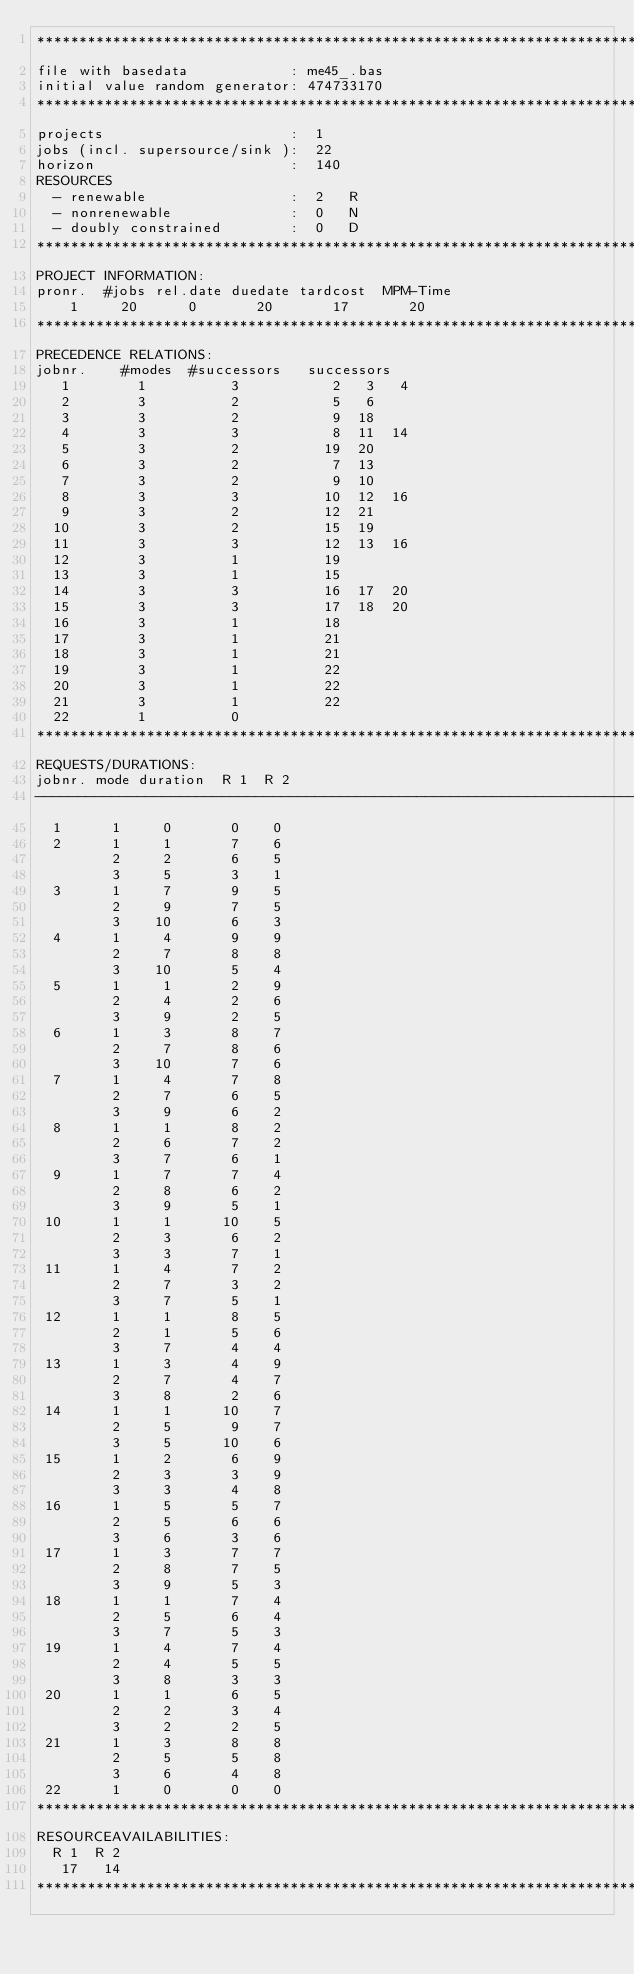Convert code to text. <code><loc_0><loc_0><loc_500><loc_500><_ObjectiveC_>************************************************************************
file with basedata            : me45_.bas
initial value random generator: 474733170
************************************************************************
projects                      :  1
jobs (incl. supersource/sink ):  22
horizon                       :  140
RESOURCES
  - renewable                 :  2   R
  - nonrenewable              :  0   N
  - doubly constrained        :  0   D
************************************************************************
PROJECT INFORMATION:
pronr.  #jobs rel.date duedate tardcost  MPM-Time
    1     20      0       20       17       20
************************************************************************
PRECEDENCE RELATIONS:
jobnr.    #modes  #successors   successors
   1        1          3           2   3   4
   2        3          2           5   6
   3        3          2           9  18
   4        3          3           8  11  14
   5        3          2          19  20
   6        3          2           7  13
   7        3          2           9  10
   8        3          3          10  12  16
   9        3          2          12  21
  10        3          2          15  19
  11        3          3          12  13  16
  12        3          1          19
  13        3          1          15
  14        3          3          16  17  20
  15        3          3          17  18  20
  16        3          1          18
  17        3          1          21
  18        3          1          21
  19        3          1          22
  20        3          1          22
  21        3          1          22
  22        1          0        
************************************************************************
REQUESTS/DURATIONS:
jobnr. mode duration  R 1  R 2
------------------------------------------------------------------------
  1      1     0       0    0
  2      1     1       7    6
         2     2       6    5
         3     5       3    1
  3      1     7       9    5
         2     9       7    5
         3    10       6    3
  4      1     4       9    9
         2     7       8    8
         3    10       5    4
  5      1     1       2    9
         2     4       2    6
         3     9       2    5
  6      1     3       8    7
         2     7       8    6
         3    10       7    6
  7      1     4       7    8
         2     7       6    5
         3     9       6    2
  8      1     1       8    2
         2     6       7    2
         3     7       6    1
  9      1     7       7    4
         2     8       6    2
         3     9       5    1
 10      1     1      10    5
         2     3       6    2
         3     3       7    1
 11      1     4       7    2
         2     7       3    2
         3     7       5    1
 12      1     1       8    5
         2     1       5    6
         3     7       4    4
 13      1     3       4    9
         2     7       4    7
         3     8       2    6
 14      1     1      10    7
         2     5       9    7
         3     5      10    6
 15      1     2       6    9
         2     3       3    9
         3     3       4    8
 16      1     5       5    7
         2     5       6    6
         3     6       3    6
 17      1     3       7    7
         2     8       7    5
         3     9       5    3
 18      1     1       7    4
         2     5       6    4
         3     7       5    3
 19      1     4       7    4
         2     4       5    5
         3     8       3    3
 20      1     1       6    5
         2     2       3    4
         3     2       2    5
 21      1     3       8    8
         2     5       5    8
         3     6       4    8
 22      1     0       0    0
************************************************************************
RESOURCEAVAILABILITIES:
  R 1  R 2
   17   14
************************************************************************
</code> 